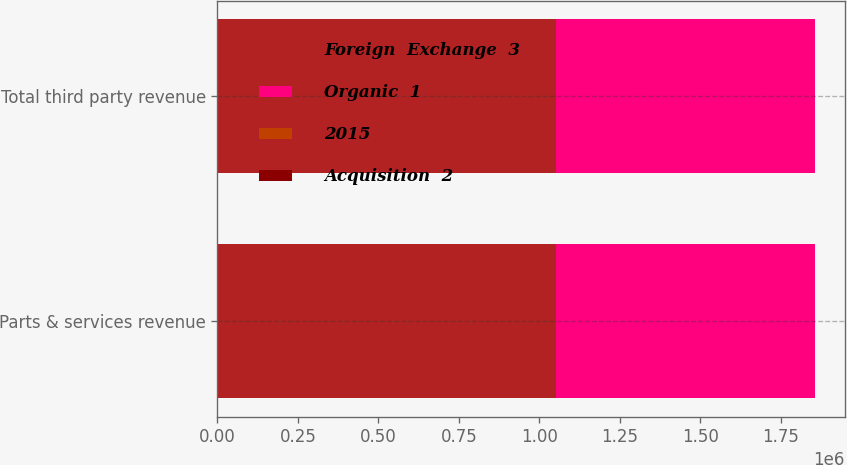Convert chart to OTSL. <chart><loc_0><loc_0><loc_500><loc_500><stacked_bar_chart><ecel><fcel>Parts & services revenue<fcel>Total third party revenue<nl><fcel>Foreign  Exchange  3<fcel>1.05125e+06<fcel>1.05125e+06<nl><fcel>Organic  1<fcel>805208<fcel>805208<nl><fcel>2015<fcel>7.8<fcel>7.8<nl><fcel>Acquisition  2<fcel>24.6<fcel>24.6<nl></chart> 